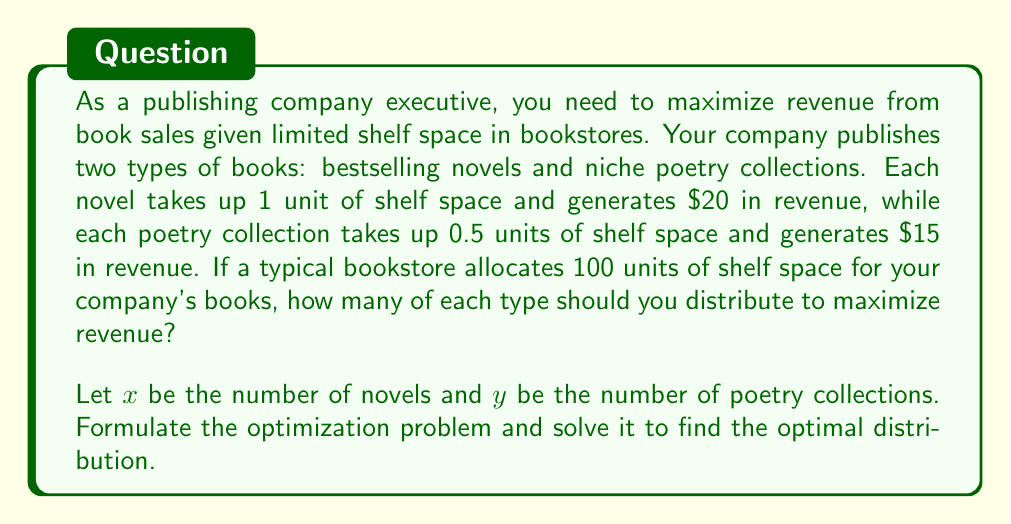What is the answer to this math problem? To solve this optimization problem, we'll follow these steps:

1. Formulate the objective function (revenue)
2. Identify the constraints
3. Set up the linear programming problem
4. Solve using the graphical method

Step 1: Objective function
Revenue = $20x + 15y$
We want to maximize this function.

Step 2: Constraints
Shelf space: $x + 0.5y \leq 100$
Non-negativity: $x \geq 0$, $y \geq 0$

Step 3: Linear programming problem
Maximize: $Z = 20x + 15y$
Subject to:
$x + 0.5y \leq 100$
$x \geq 0$, $y \geq 0$

Step 4: Graphical method
a) Plot the constraint: $x + 0.5y = 100$
This line intersects the x-axis at (100, 0) and the y-axis at (0, 200).

b) The feasible region is the area below this line in the first quadrant.

c) Plot the objective function lines:
$20x + 15y = k$, where k is a constant.

d) Find the optimal point by moving the objective function line outward until it reaches the furthest point in the feasible region.

The optimal point will be at the corner point (100, 0), which represents 100 novels and 0 poetry collections.

To verify, let's check the other corner point (0, 200):
At (100, 0): Revenue = 20(100) + 15(0) = $2000
At (0, 200): Revenue = 20(0) + 15(200) = $3000

Therefore, the optimal solution is to distribute 0 novels and 200 poetry collections.
Answer: The optimal distribution to maximize revenue is 0 novels and 200 poetry collections, generating a total revenue of $3000. 